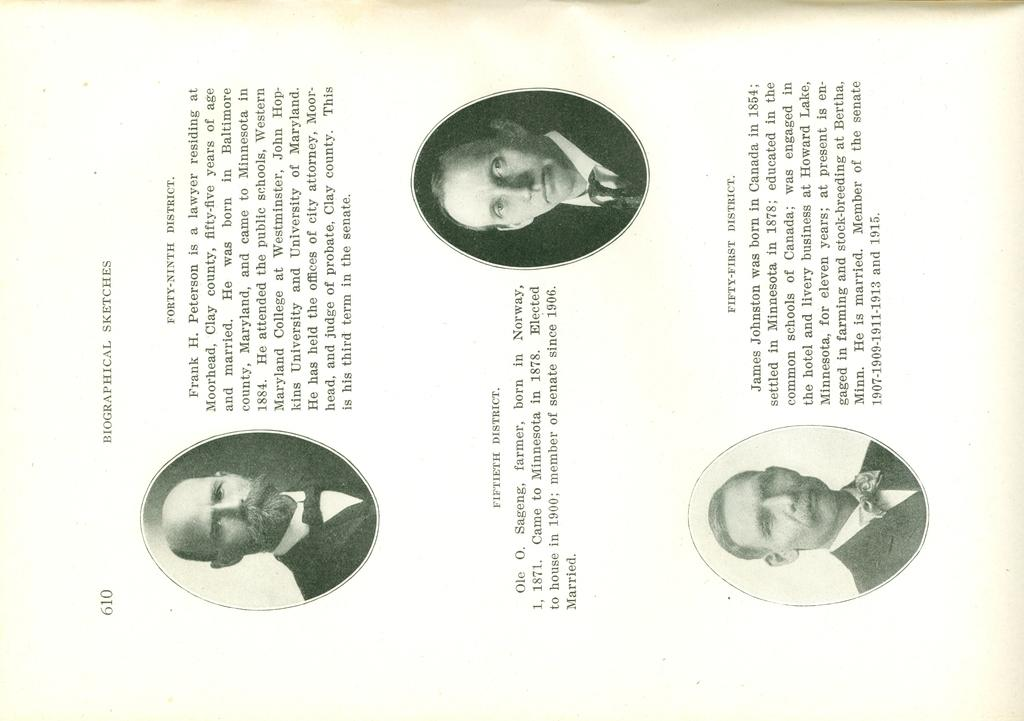What is the main object in the image? There is a paper in the image. What can be seen on the paper? The paper contains photographs of three persons. Are there any words on the paper? Yes, there is printed text on the paper. What type of feeling does the paper have in the image? The paper does not have feelings, as it is an inanimate object. 